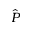<formula> <loc_0><loc_0><loc_500><loc_500>\hat { P }</formula> 